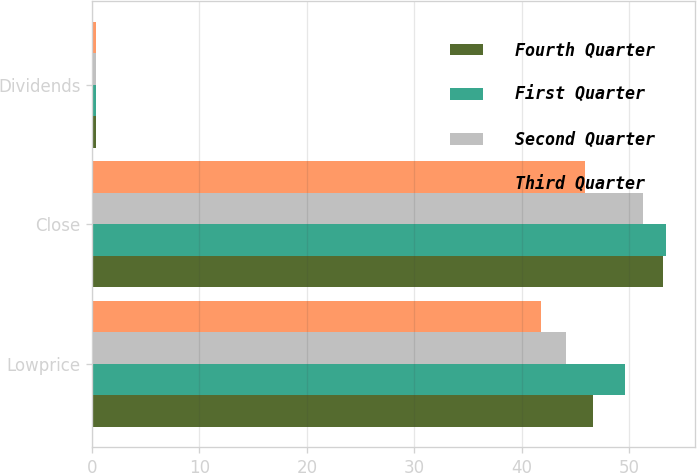Convert chart to OTSL. <chart><loc_0><loc_0><loc_500><loc_500><stacked_bar_chart><ecel><fcel>Lowprice<fcel>Close<fcel>Dividends<nl><fcel>Fourth Quarter<fcel>46.62<fcel>53.14<fcel>0.4<nl><fcel>First Quarter<fcel>49.6<fcel>53.44<fcel>0.4<nl><fcel>Second Quarter<fcel>44.14<fcel>51.33<fcel>0.4<nl><fcel>Third Quarter<fcel>41.77<fcel>45.89<fcel>0.4<nl></chart> 